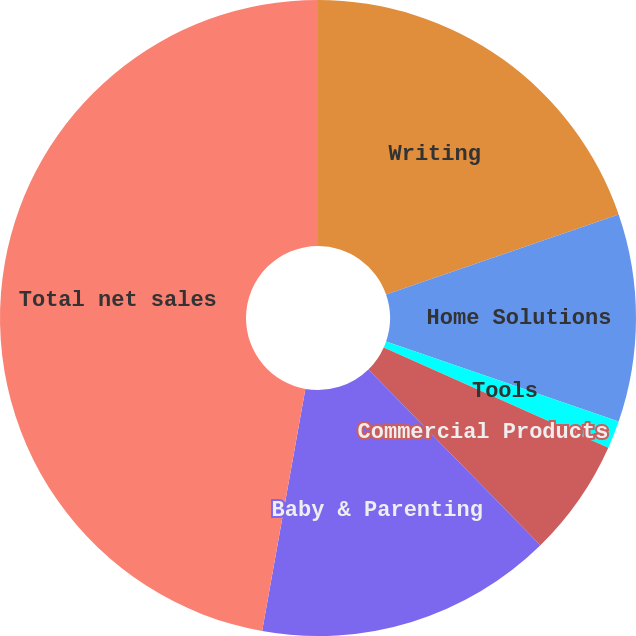Convert chart to OTSL. <chart><loc_0><loc_0><loc_500><loc_500><pie_chart><fcel>Writing<fcel>Home Solutions<fcel>Tools<fcel>Commercial Products<fcel>Baby & Parenting<fcel>Total net sales<nl><fcel>19.72%<fcel>10.56%<fcel>1.41%<fcel>5.98%<fcel>15.14%<fcel>47.19%<nl></chart> 